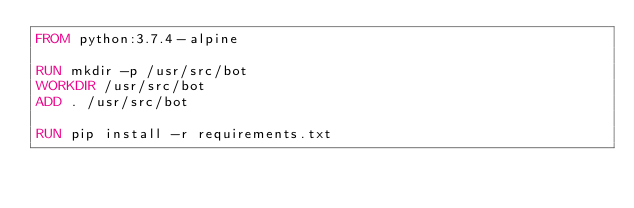Convert code to text. <code><loc_0><loc_0><loc_500><loc_500><_Dockerfile_>FROM python:3.7.4-alpine

RUN mkdir -p /usr/src/bot
WORKDIR /usr/src/bot
ADD . /usr/src/bot

RUN pip install -r requirements.txt
</code> 